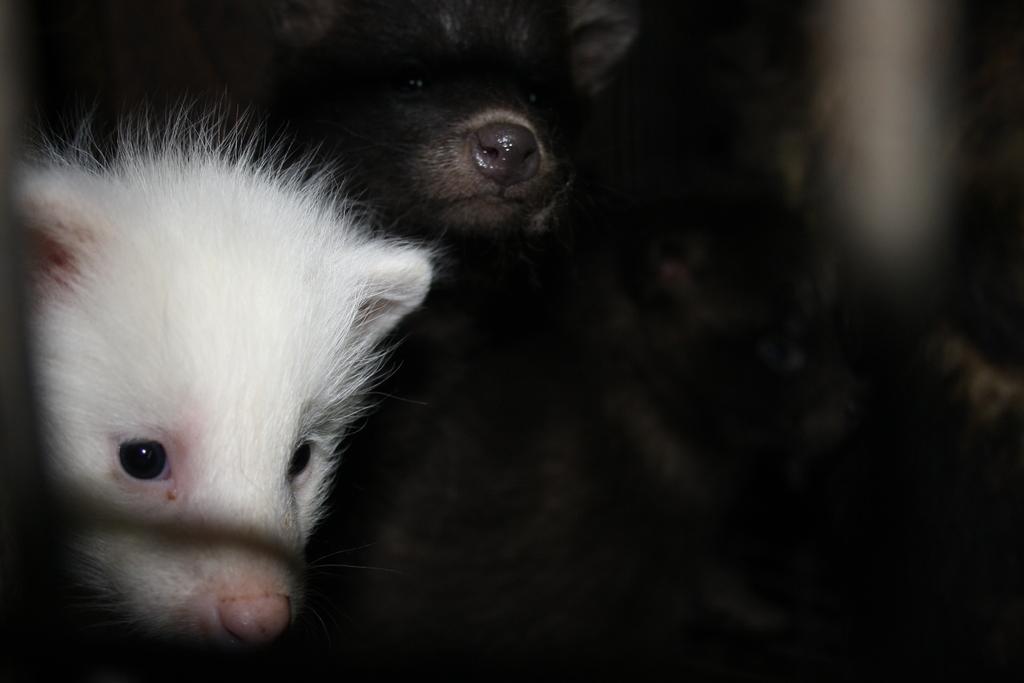In one or two sentences, can you explain what this image depicts? In the picture I can see animals. These animals are white and black in color. The background of the image is dark. 